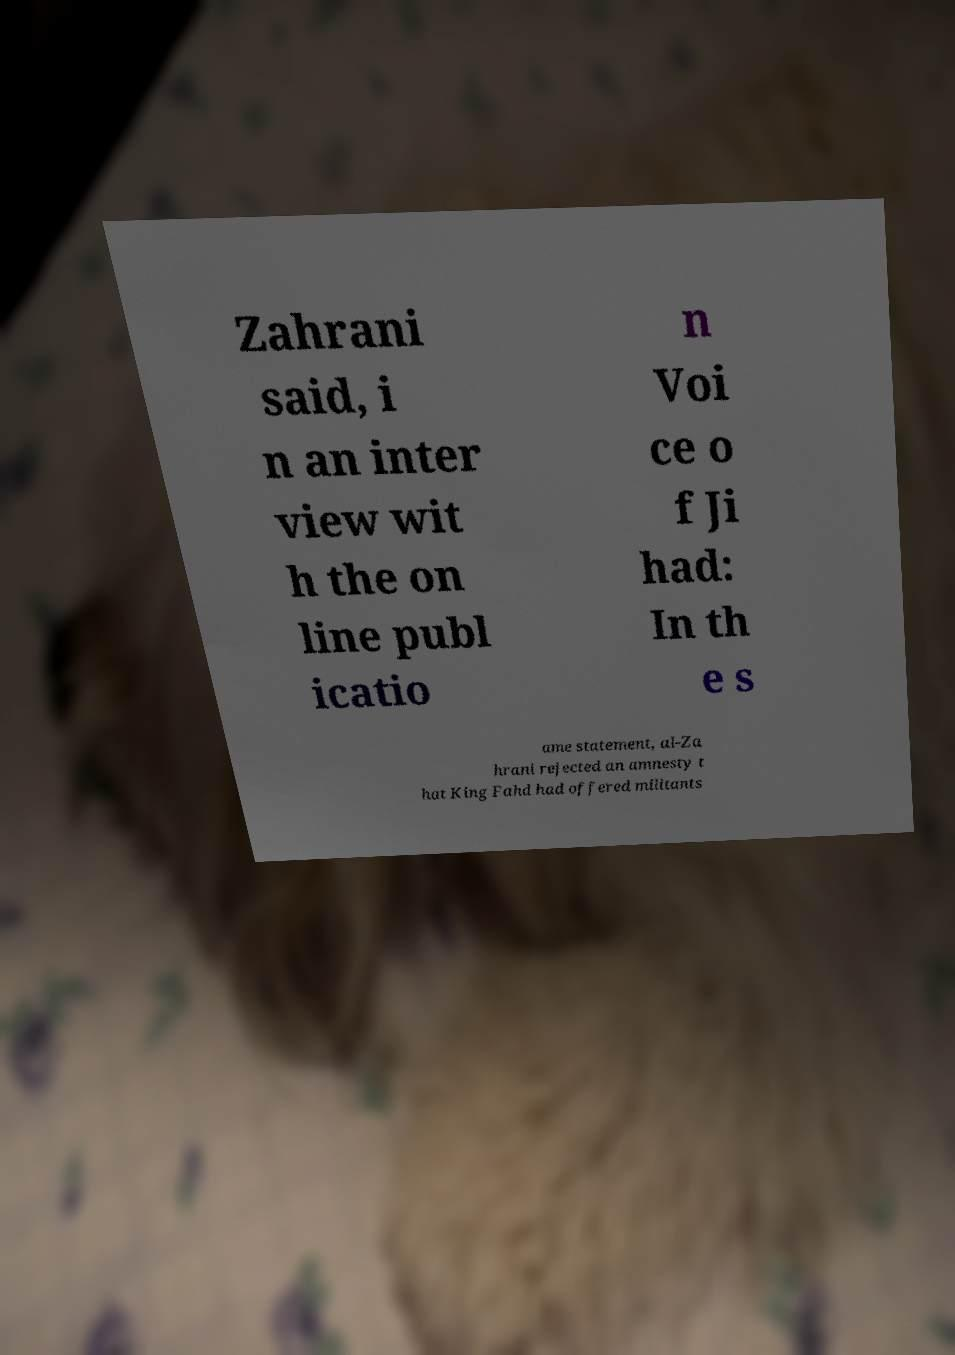Please read and relay the text visible in this image. What does it say? Zahrani said, i n an inter view wit h the on line publ icatio n Voi ce o f Ji had: In th e s ame statement, al-Za hrani rejected an amnesty t hat King Fahd had offered militants 